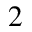<formula> <loc_0><loc_0><loc_500><loc_500>^ { 2 }</formula> 